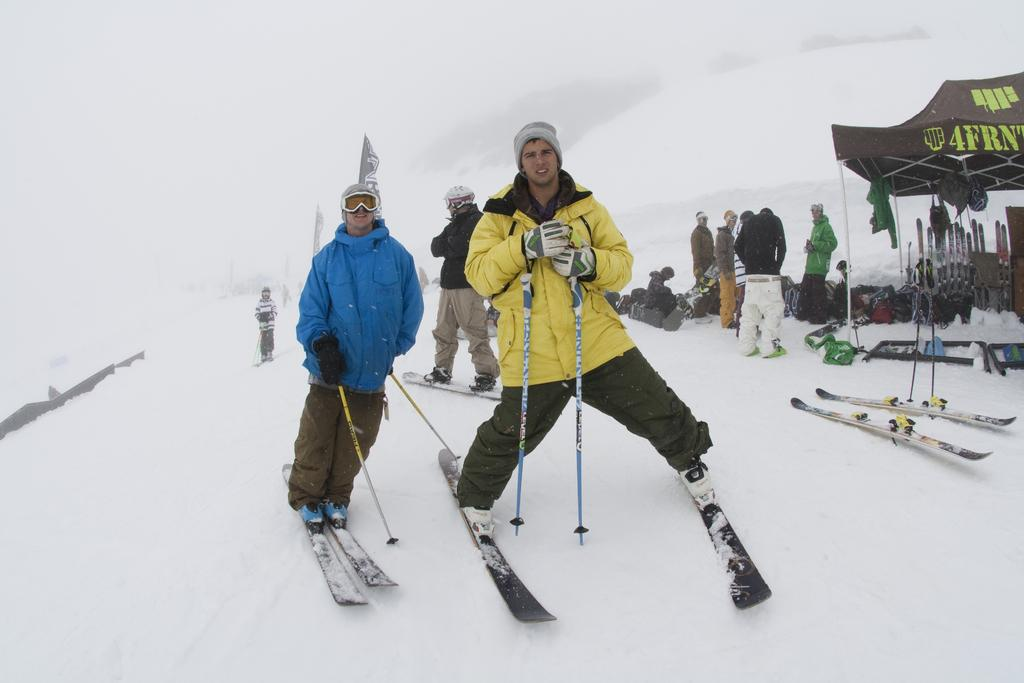How many people are in the image? There are people in the image, but the exact number is not specified. What are some people doing in the image? Some people are standing on skis in the image. What type of shelter is present in the image? There is a tent in the image. What equipment is visible in the image? Skis and bags are visible in the image. What decorative or symbolic items are present in the image? Flags are present in the image. What is the condition of the ground in the image? The ground appears to be covered in snow. What type of selection process is taking place in the library depicted in the image? There is no library present in the image, and therefore no selection process can be observed. 